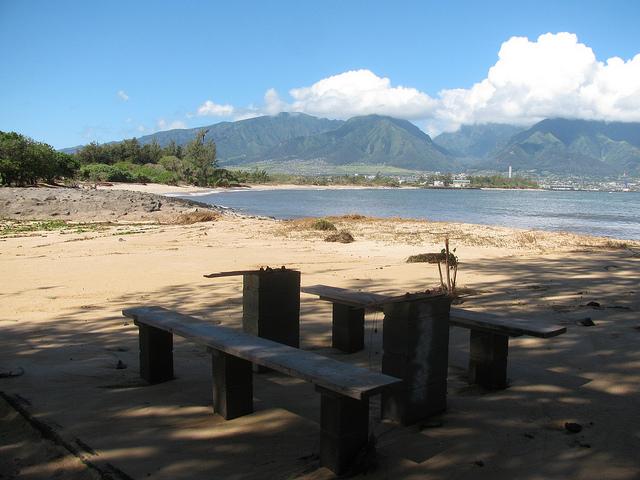What color is the bench?
Short answer required. Brown. Is there a bird in the photo?
Keep it brief. No. How many benches are there?
Keep it brief. 2. What are the wooden objects used for?
Keep it brief. Sitting. Is there more than five people visibly enjoying the beach in this photo?
Answer briefly. No. 